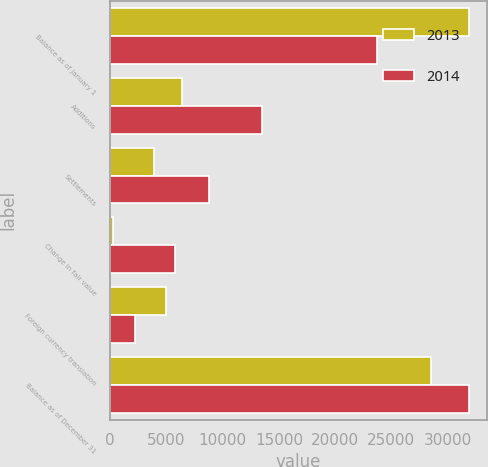Convert chart. <chart><loc_0><loc_0><loc_500><loc_500><stacked_bar_chart><ecel><fcel>Balance as of January 1<fcel>Additions<fcel>Settlements<fcel>Change in fair value<fcel>Foreign currency translation<fcel>Balance as of December 31<nl><fcel>2013<fcel>31890<fcel>6412<fcel>3889<fcel>225<fcel>4934<fcel>28524<nl><fcel>2014<fcel>23711<fcel>13474<fcel>8789<fcel>5743<fcel>2249<fcel>31890<nl></chart> 